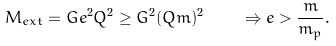Convert formula to latex. <formula><loc_0><loc_0><loc_500><loc_500>M _ { e x t } = G e ^ { 2 } Q ^ { 2 } \geq G ^ { 2 } ( Q m ) ^ { 2 } \quad \Rightarrow e > \frac { m } { m _ { p } } .</formula> 